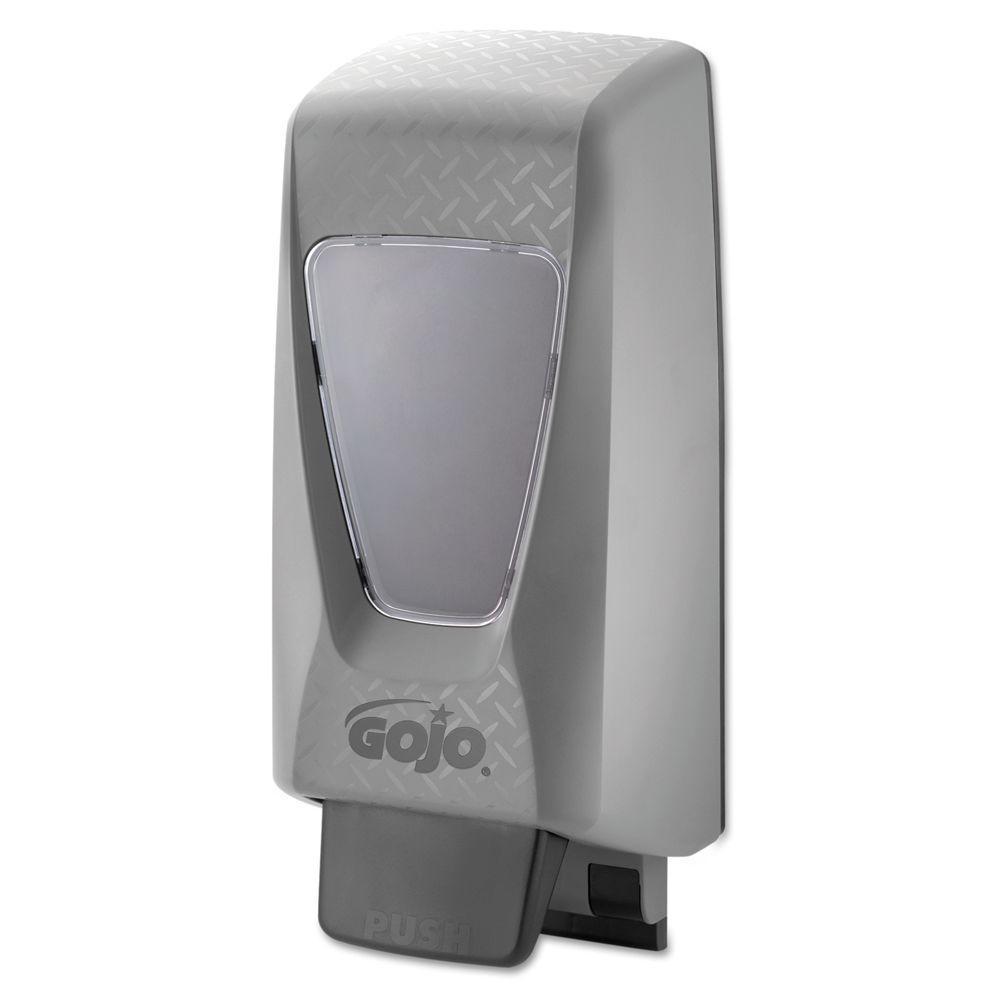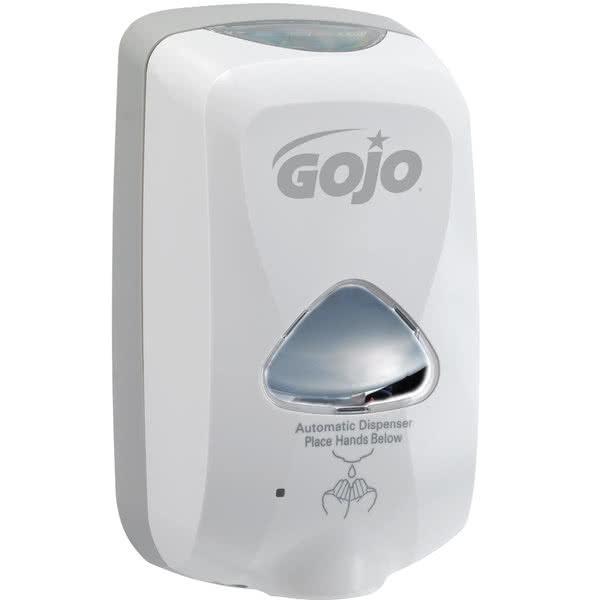The first image is the image on the left, the second image is the image on the right. Analyze the images presented: Is the assertion "There is exactly one white dispenser." valid? Answer yes or no. Yes. The first image is the image on the left, the second image is the image on the right. For the images displayed, is the sentence "One of the soap dispensers is significantly darker than the other." factually correct? Answer yes or no. Yes. 